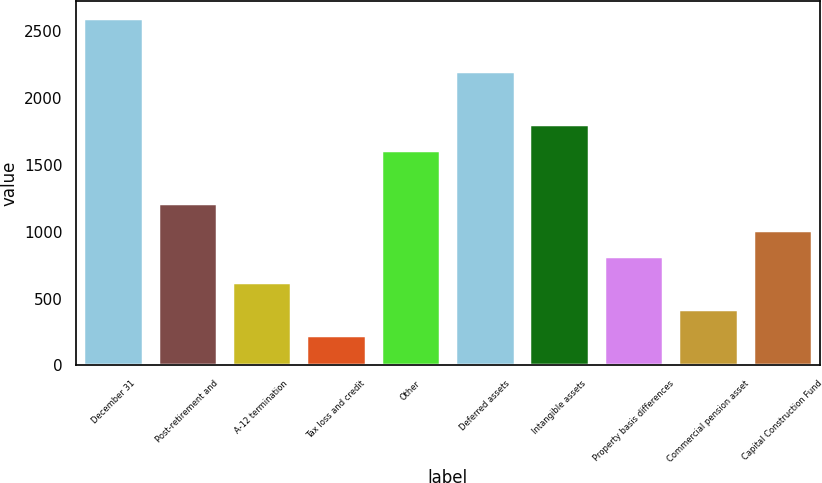<chart> <loc_0><loc_0><loc_500><loc_500><bar_chart><fcel>December 31<fcel>Post-retirement and<fcel>A-12 termination<fcel>Tax loss and credit<fcel>Other<fcel>Deferred assets<fcel>Intangible assets<fcel>Property basis differences<fcel>Commercial pension asset<fcel>Capital Construction Fund<nl><fcel>2599.1<fcel>1215.2<fcel>622.1<fcel>226.7<fcel>1610.6<fcel>2203.7<fcel>1808.3<fcel>819.8<fcel>424.4<fcel>1017.5<nl></chart> 